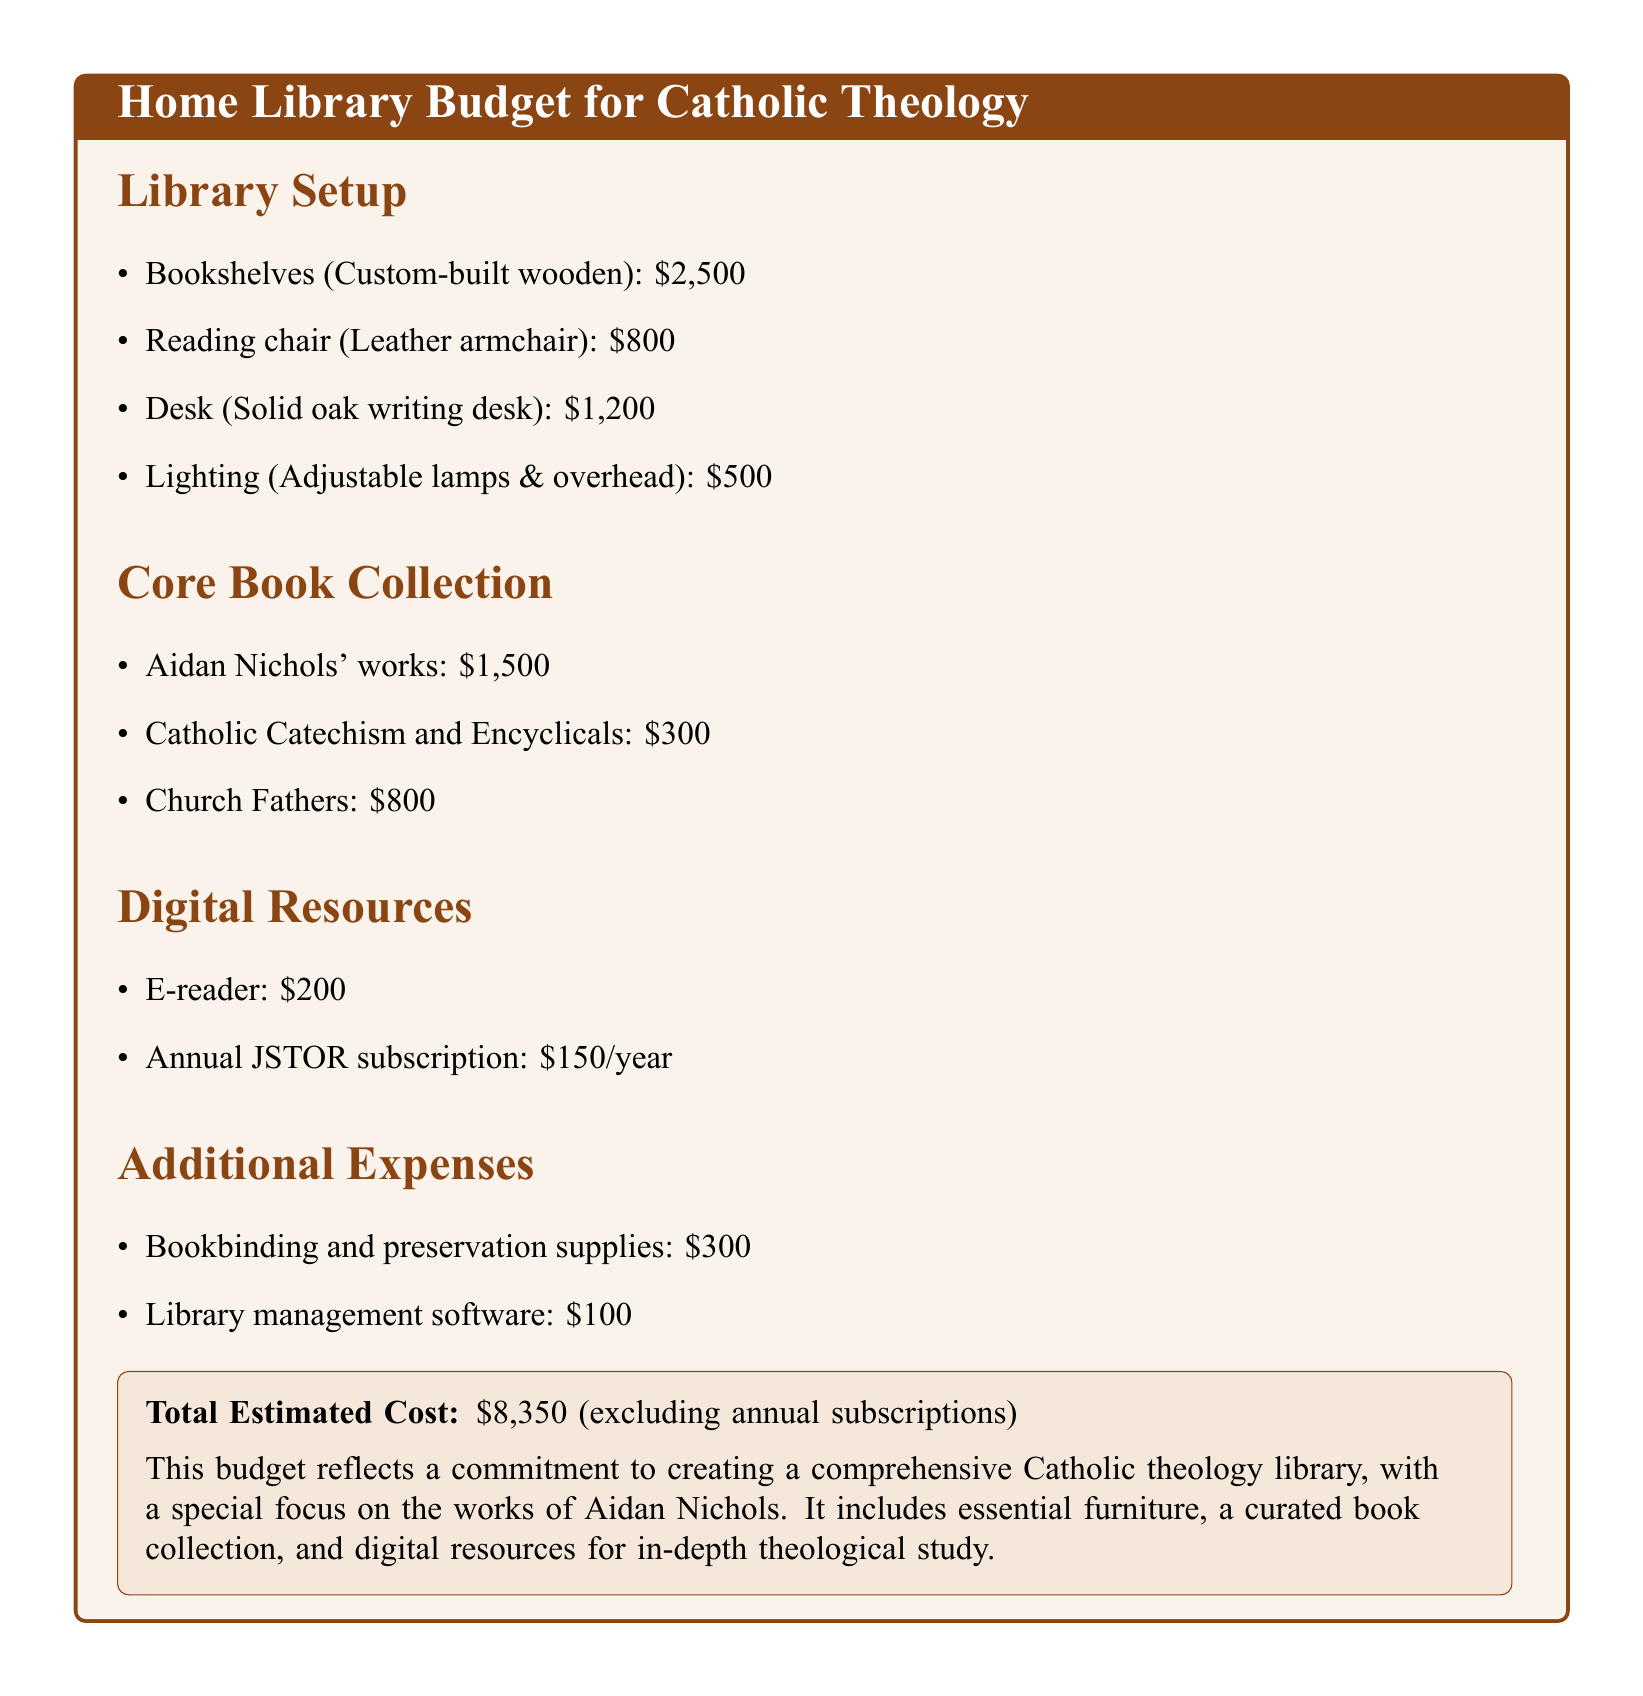What is the total estimated cost? The total estimated cost is clearly stated in the document as $8,350.
Answer: $8,350 How much is allocated for Aidan Nichols' works? The document specifies the amount set aside for Aidan Nichols' works as part of the core book collection.
Answer: $1,500 What type of reading chair is included in the budget? The document describes the reading chair as a leather armchair, indicating its type and material.
Answer: Leather armchair How much is budgeted for library management software? The amount allocated for library management software is explicitly mentioned in the additional expenses section.
Answer: $100 What is the cost of the annual JSTOR subscription? The document lists the cost for the annual JSTOR subscription within the digital resources.
Answer: $150/year What item contributes most to the furniture costs? The custom-built wooden bookshelves have the highest cost among the listed furniture items.
Answer: $2,500 What is included in the core book collection besides Aidan Nichols' works? The core book collection also includes the Catholic Catechism and Church Fathers, as stated in the document.
Answer: Catholic Catechism and Church Fathers How much is budgeted for lighting? The budget specifically earmarks a certain amount for lighting, as detailed in the library setup section.
Answer: $500 